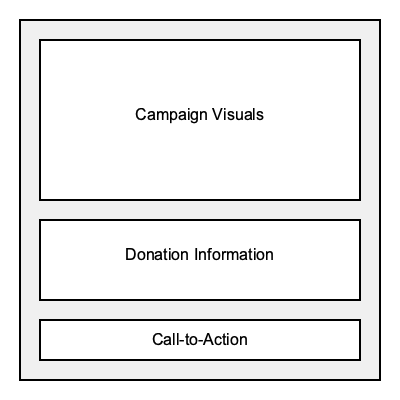In designing a social media post template for a fundraising campaign, what is the optimal ratio of space allocated for campaign visuals compared to donation information, based on the diagram? To determine the optimal ratio of space allocated for campaign visuals compared to donation information, we need to analyze the diagram and calculate the areas dedicated to each element:

1. Calculate the area for campaign visuals:
   Width = 320 pixels
   Height = 160 pixels
   Area = 320 * 160 = 51,200 square pixels

2. Calculate the area for donation information:
   Width = 320 pixels
   Height = 80 pixels
   Area = 320 * 80 = 25,600 square pixels

3. Calculate the ratio:
   Ratio = Area of campaign visuals : Area of donation information
   Ratio = 51,200 : 25,600
   Simplify the ratio by dividing both numbers by their greatest common divisor (25,600):
   Ratio = (51,200 / 25,600) : (25,600 / 25,600)
   Ratio = 2 : 1

Therefore, the optimal ratio of space allocated for campaign visuals compared to donation information is 2:1.
Answer: 2:1 